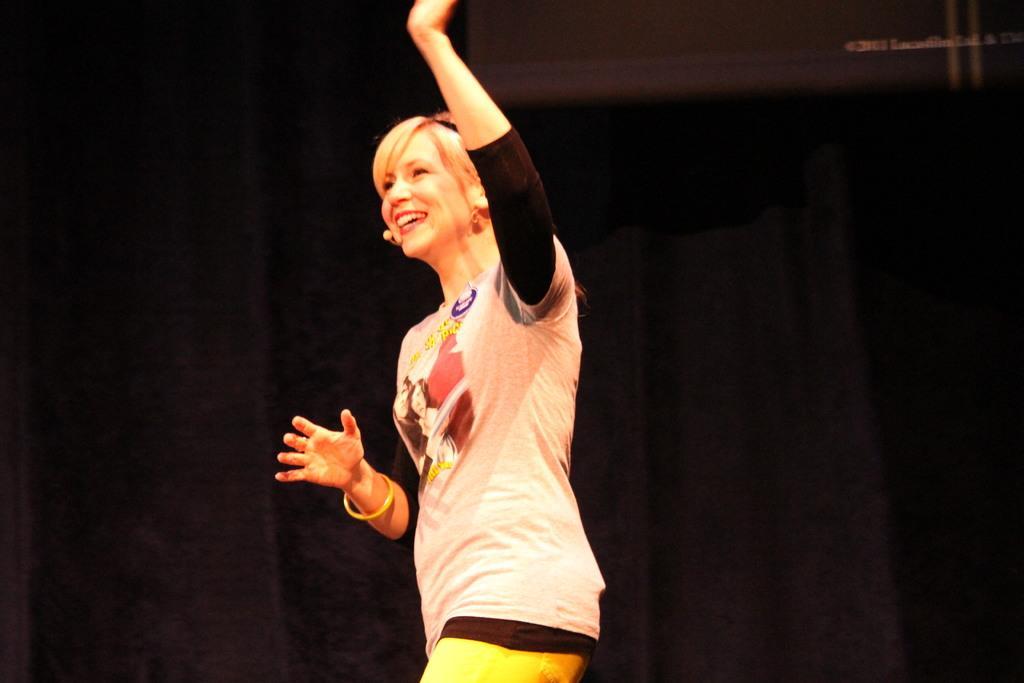Please provide a concise description of this image. In this image there is a lady standing, in the background there is a black curtain. 